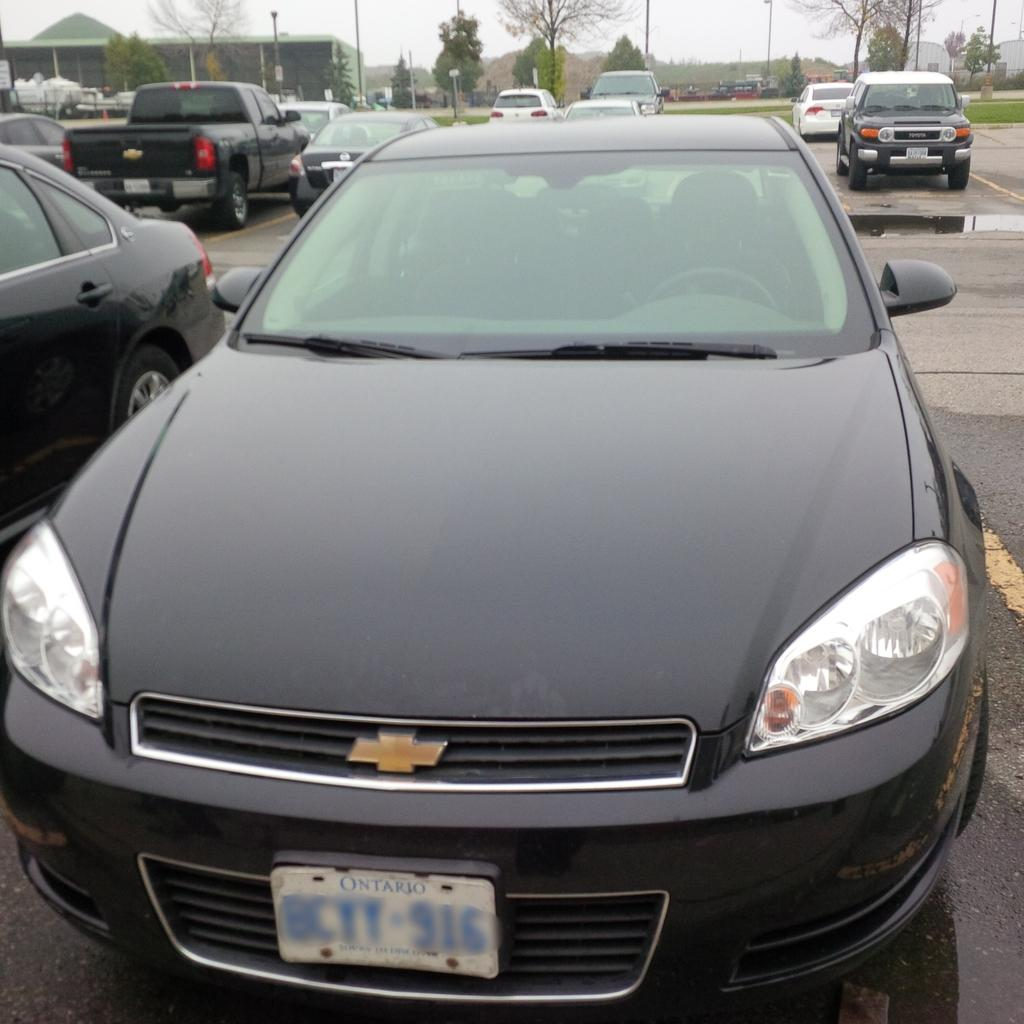What type of view is shown in the image? The image is an outside view. What can be seen on the ground in the image? There are many cars on the ground. What is visible in the background of the image? There are trees and a house in the background. What is visible at the top of the image? The sky is visible at the top of the image. How does the ice affect the movement of the cars in the image? There is no ice present in the image, so it does not affect the movement of the cars. What arm is visible in the image? There are no arms visible in the image. 